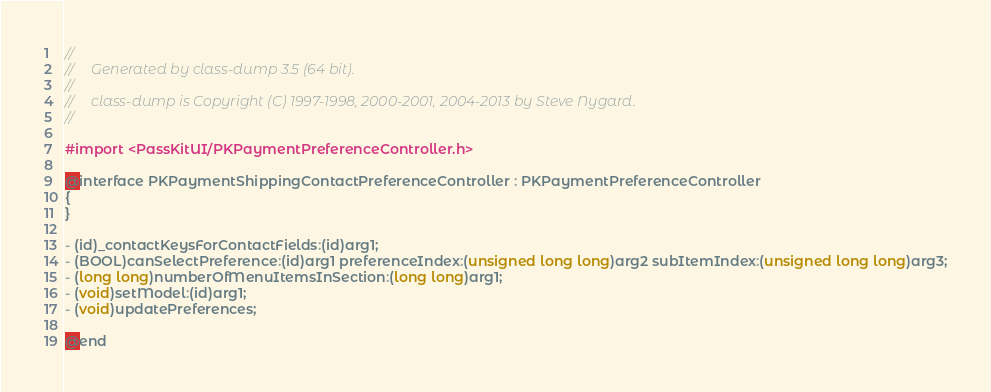Convert code to text. <code><loc_0><loc_0><loc_500><loc_500><_C_>//
//     Generated by class-dump 3.5 (64 bit).
//
//     class-dump is Copyright (C) 1997-1998, 2000-2001, 2004-2013 by Steve Nygard.
//

#import <PassKitUI/PKPaymentPreferenceController.h>

@interface PKPaymentShippingContactPreferenceController : PKPaymentPreferenceController
{
}

- (id)_contactKeysForContactFields:(id)arg1;
- (BOOL)canSelectPreference:(id)arg1 preferenceIndex:(unsigned long long)arg2 subItemIndex:(unsigned long long)arg3;
- (long long)numberOfMenuItemsInSection:(long long)arg1;
- (void)setModel:(id)arg1;
- (void)updatePreferences;

@end

</code> 